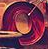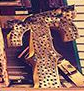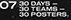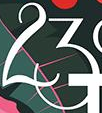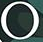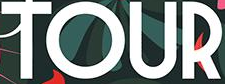Read the text content from these images in order, separated by a semicolon. O; T; #; 23; °; TOUR 